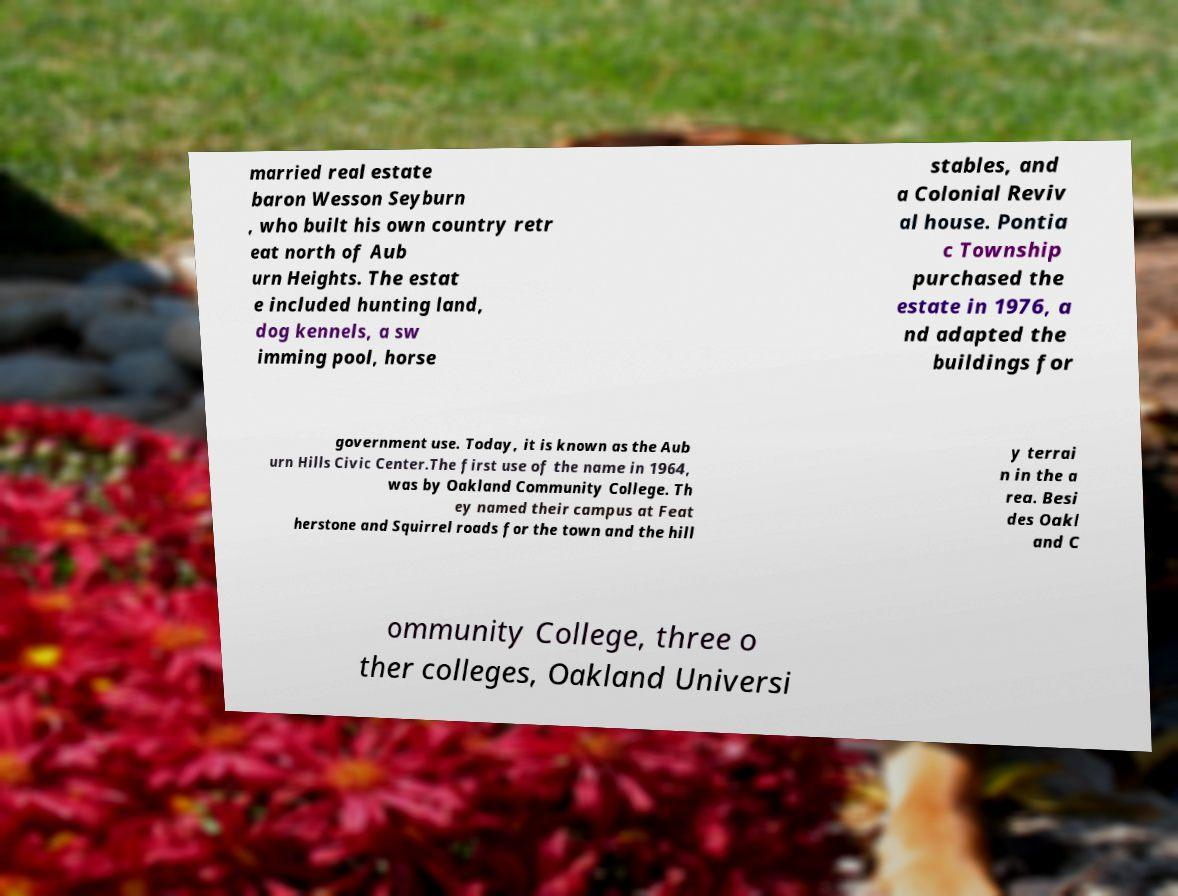I need the written content from this picture converted into text. Can you do that? married real estate baron Wesson Seyburn , who built his own country retr eat north of Aub urn Heights. The estat e included hunting land, dog kennels, a sw imming pool, horse stables, and a Colonial Reviv al house. Pontia c Township purchased the estate in 1976, a nd adapted the buildings for government use. Today, it is known as the Aub urn Hills Civic Center.The first use of the name in 1964, was by Oakland Community College. Th ey named their campus at Feat herstone and Squirrel roads for the town and the hill y terrai n in the a rea. Besi des Oakl and C ommunity College, three o ther colleges, Oakland Universi 